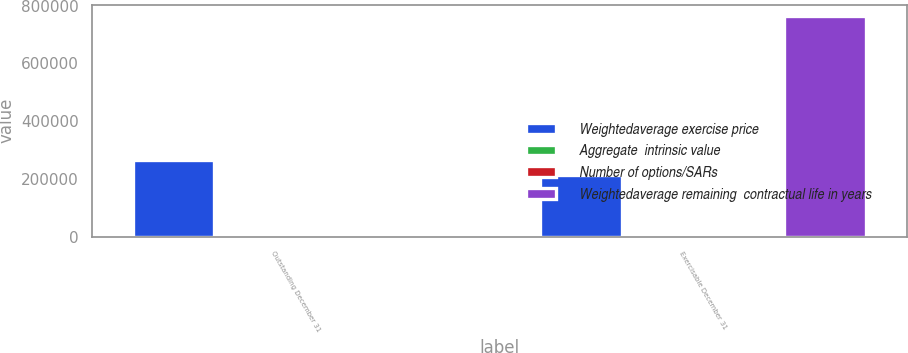Convert chart. <chart><loc_0><loc_0><loc_500><loc_500><stacked_bar_chart><ecel><fcel>Outstanding December 31<fcel>Exercisable December 31<nl><fcel>Weightedaverage exercise price<fcel>266568<fcel>214443<nl><fcel>Aggregate  intrinsic value<fcel>45.83<fcel>48.94<nl><fcel>Number of options/SARs<fcel>3.4<fcel>2.2<nl><fcel>Weightedaverage remaining  contractual life in years<fcel>48.94<fcel>765276<nl></chart> 